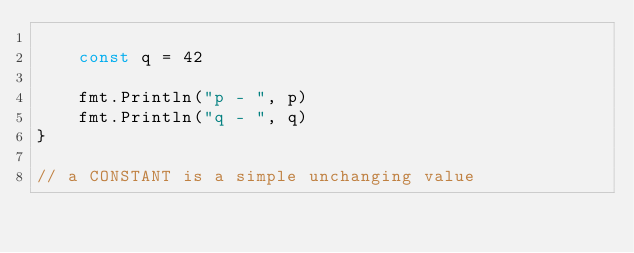<code> <loc_0><loc_0><loc_500><loc_500><_Go_>
	const q = 42

	fmt.Println("p - ", p)
	fmt.Println("q - ", q)
}

// a CONSTANT is a simple unchanging value
</code> 